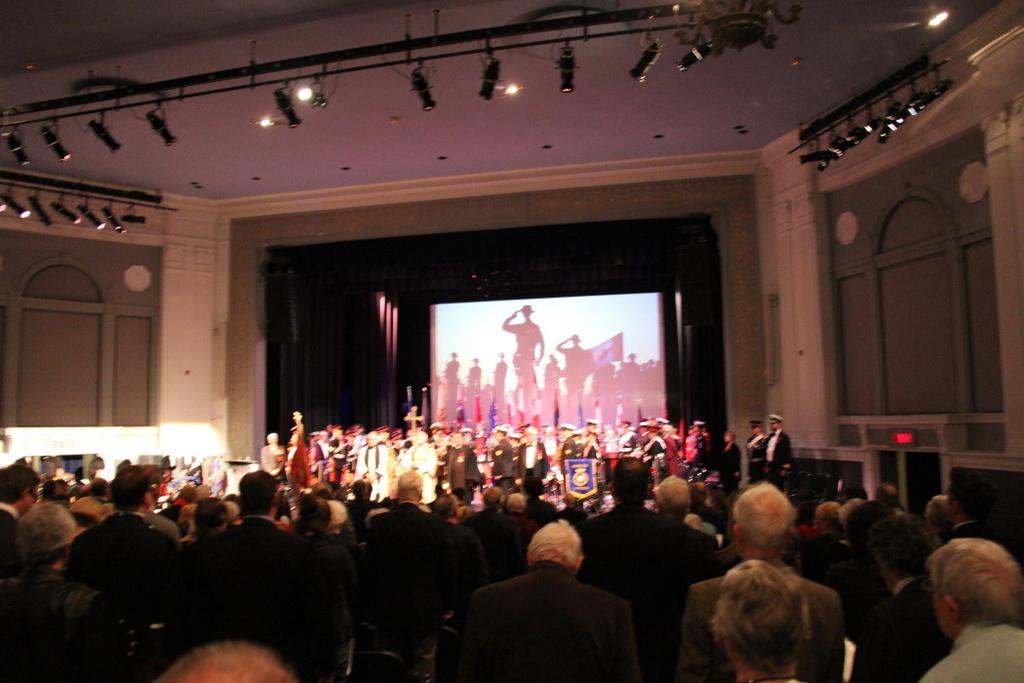What is happening on the stage in the image? There are persons standing on the stage. Who else is present in the image? There are other persons standing in front of them. What can be seen above the persons on the stage? There are lights above the persons on the stage. Can you tell me how many clocks are visible on the stage? There is no clock present on the stage in the image. What type of steam is being produced by the persons on the stage? There is no steam being produced by the persons on the stage in the image. 